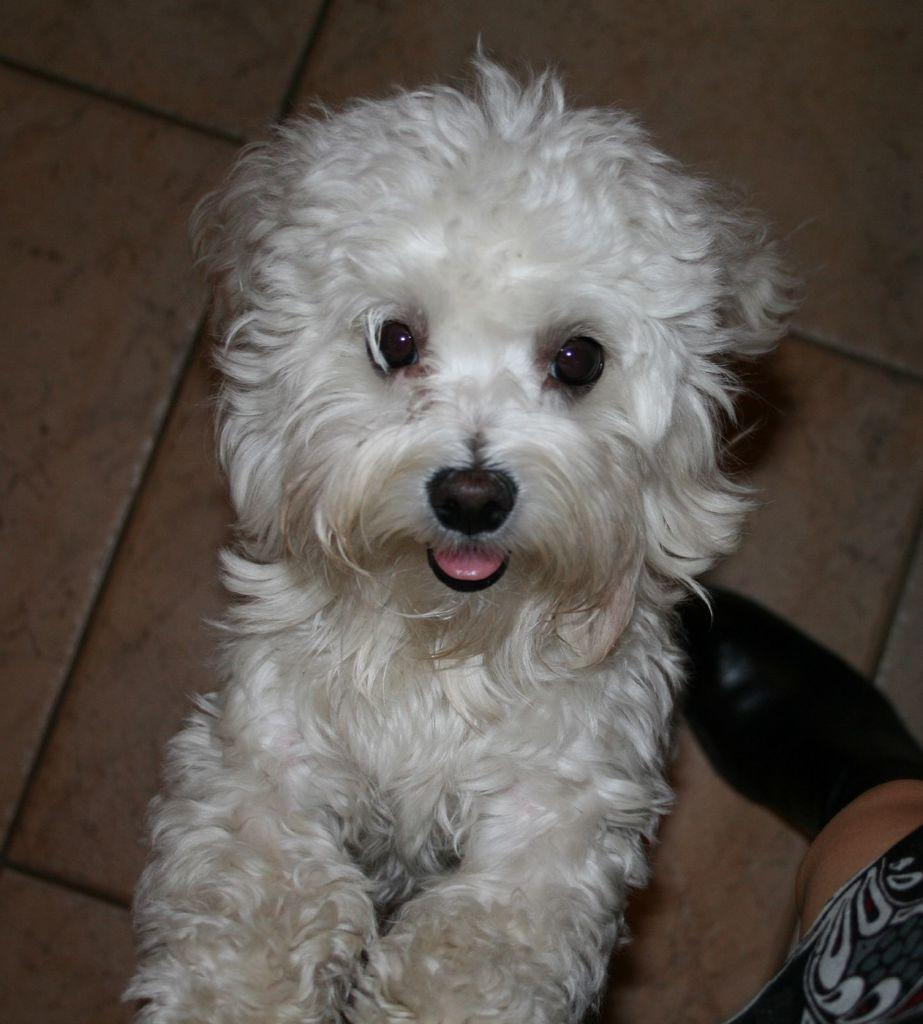What type of flooring is visible in the image? The floor in the image has tiles. What animal can be seen in the image? There is a dog in the image. What is the color of the dog? The dog is white in color. How is the dog's fur described? The dog has a full coat of fur. Can you see the dog's lip in the image? There is no mention of the dog's lip in the provided facts, and therefore it cannot be determined if it is visible in the image. 